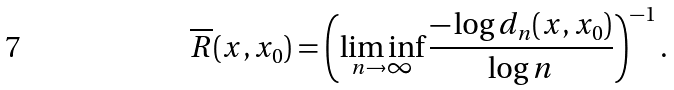Convert formula to latex. <formula><loc_0><loc_0><loc_500><loc_500>\overline { R } ( x , x _ { 0 } ) = \left ( \liminf _ { n \rightarrow \infty } \frac { - \log d _ { n } ( x , x _ { 0 } ) } { \log n } \right ) ^ { - 1 } .</formula> 